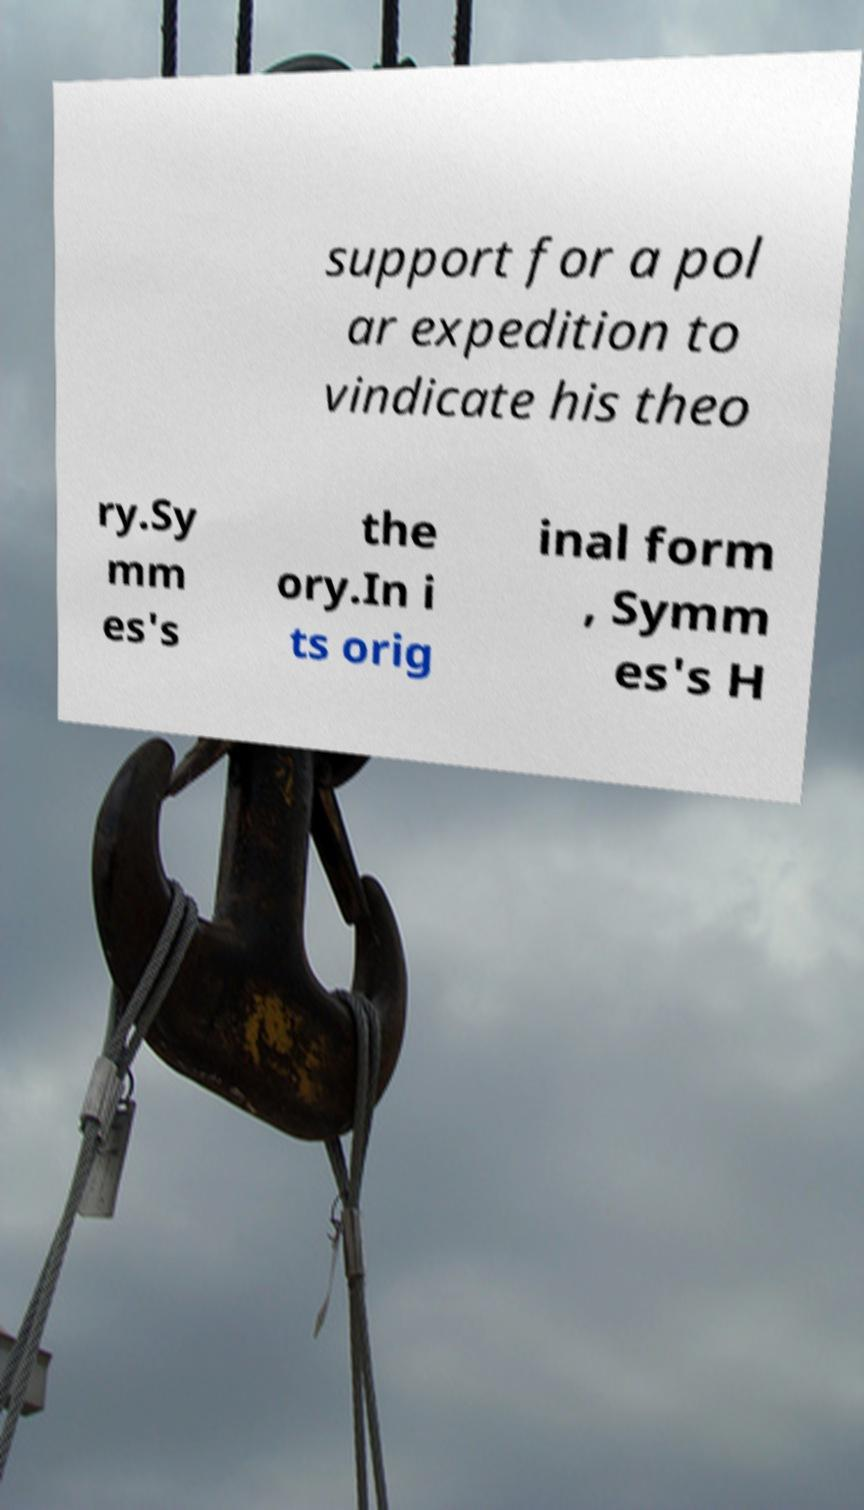For documentation purposes, I need the text within this image transcribed. Could you provide that? support for a pol ar expedition to vindicate his theo ry.Sy mm es's the ory.In i ts orig inal form , Symm es's H 